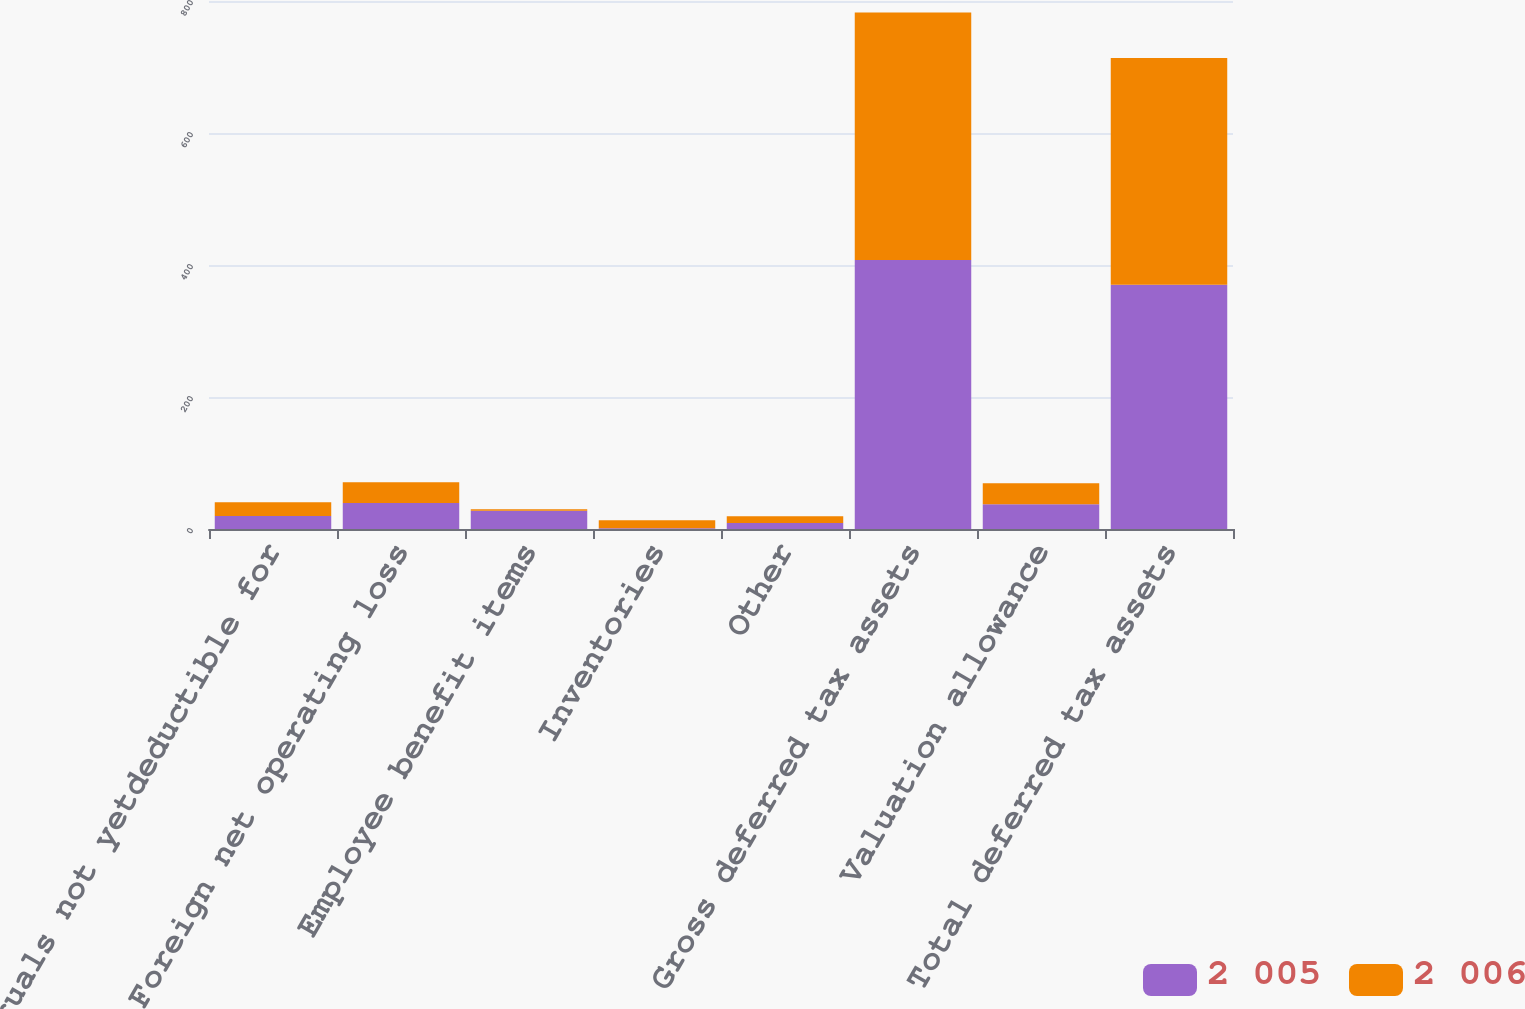Convert chart. <chart><loc_0><loc_0><loc_500><loc_500><stacked_bar_chart><ecel><fcel>Accruals not yetdeductible for<fcel>Foreign net operating loss<fcel>Employee benefit items<fcel>Inventories<fcel>Other<fcel>Gross deferred tax assets<fcel>Valuation allowance<fcel>Total deferred tax assets<nl><fcel>2 005<fcel>19.7<fcel>39.3<fcel>27.6<fcel>1.3<fcel>9<fcel>407.6<fcel>37.6<fcel>370<nl><fcel>2 006<fcel>20.8<fcel>31.6<fcel>2.5<fcel>12.1<fcel>10.5<fcel>375.1<fcel>31.6<fcel>343.5<nl></chart> 